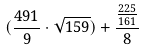Convert formula to latex. <formula><loc_0><loc_0><loc_500><loc_500>( \frac { 4 9 1 } { 9 } \cdot \sqrt { 1 5 9 } ) + \frac { \frac { 2 2 5 } { 1 6 1 } } { 8 }</formula> 